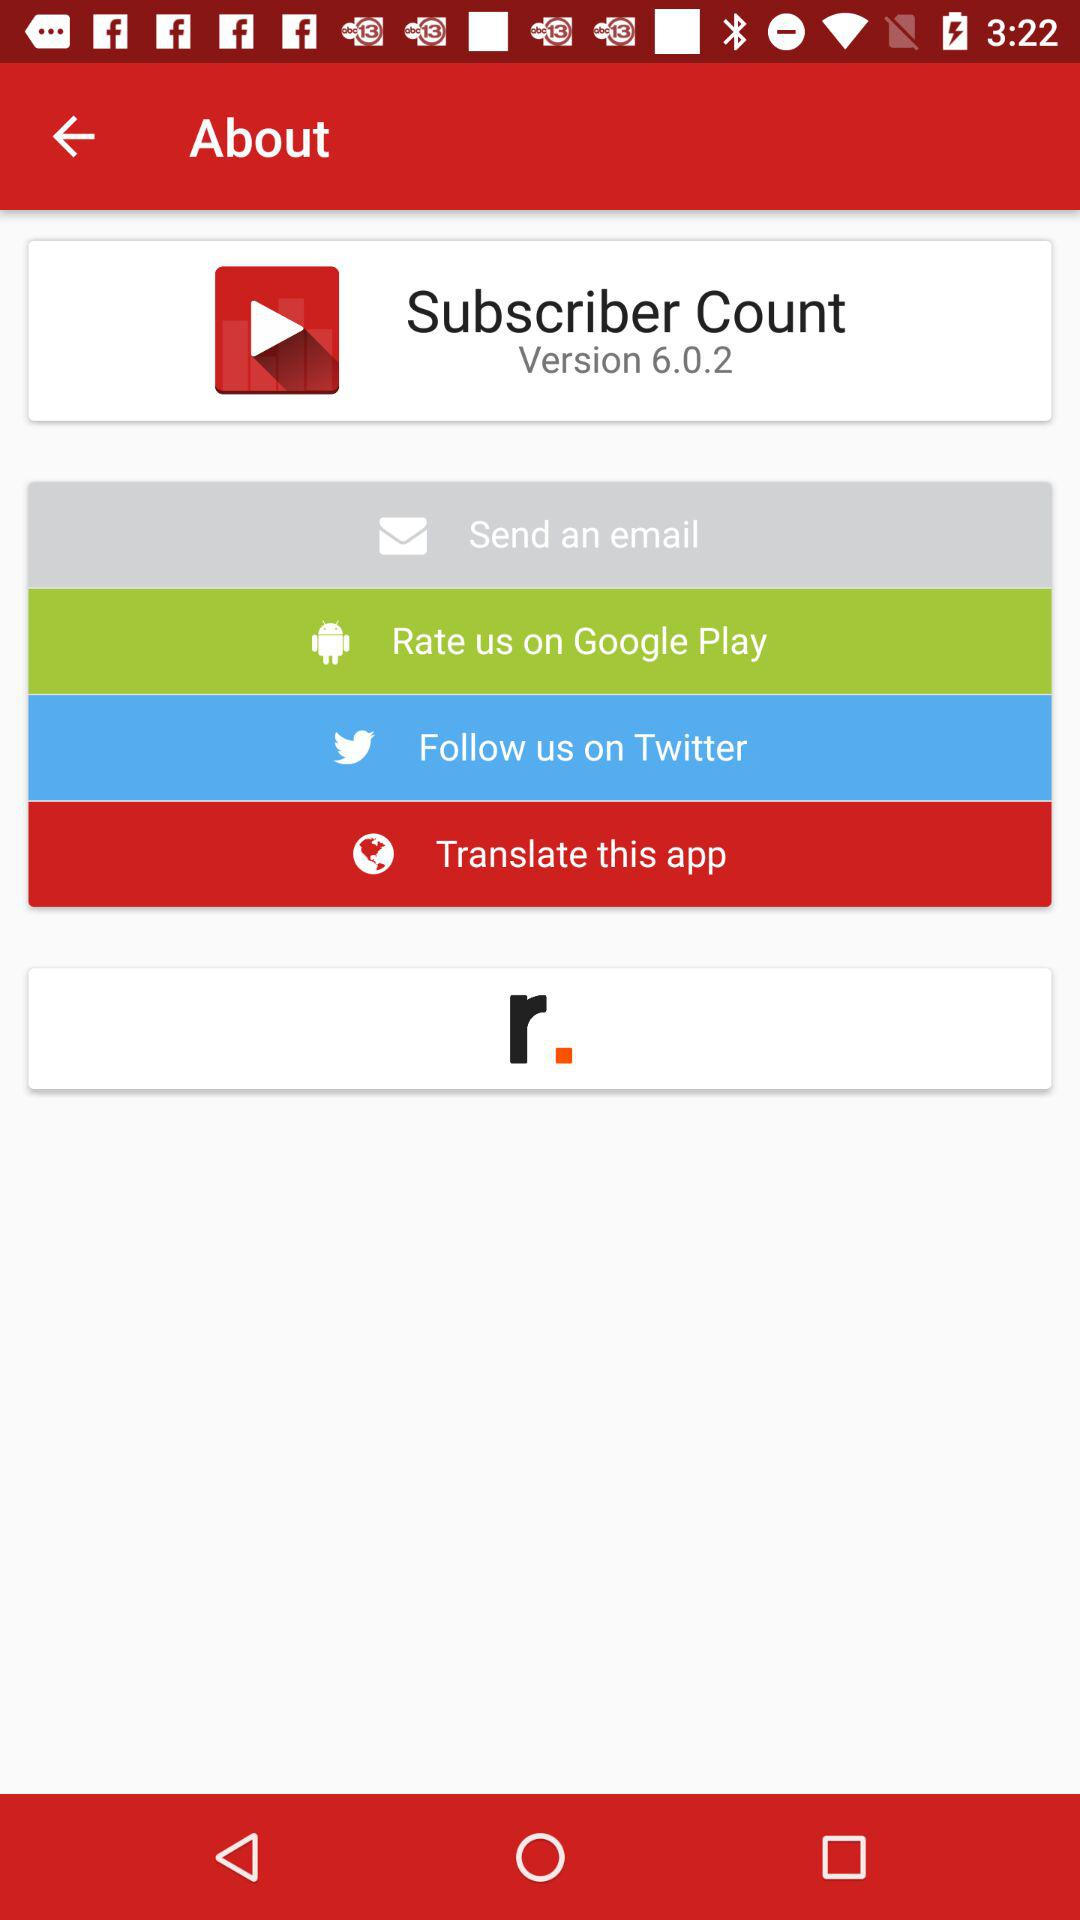What version are we using in the "Subscriber Count"? The version is 6.0.2. 